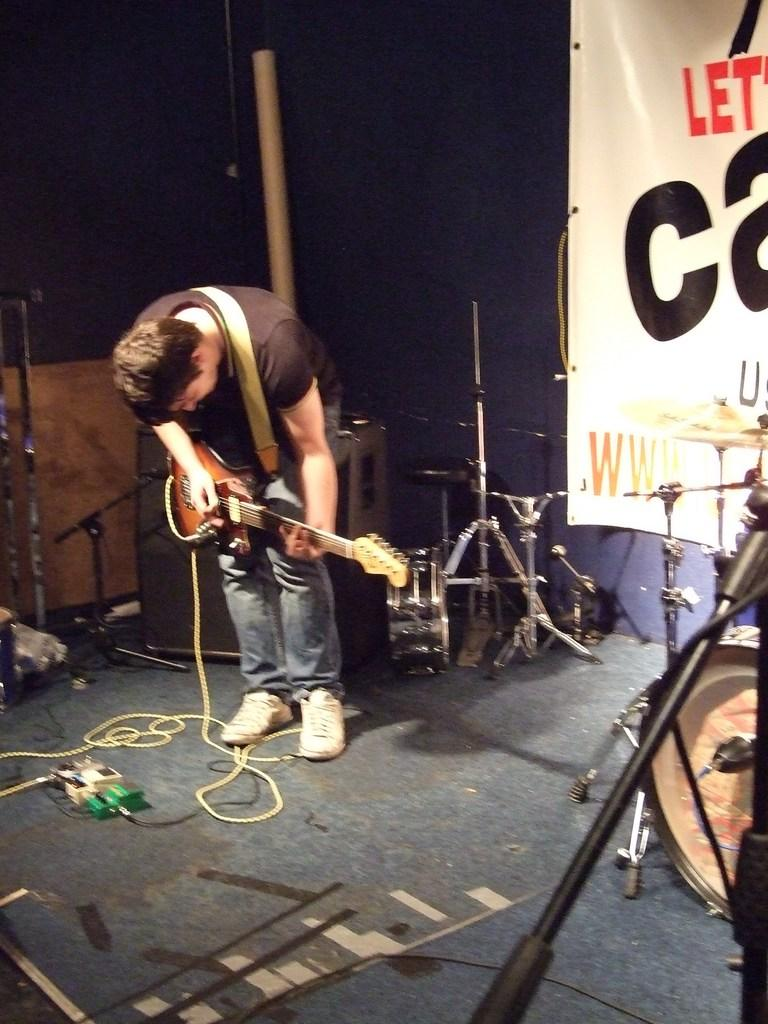Who is the main subject in the image? There is a man in the image. What is the man doing in the image? The man is playing a guitar. Where is the man located in the image? The man is on a stage. What other musical instruments can be seen in the image? There are other musical instruments in the image. What day of the week is the goose performing on the stage in the image? There is no goose present in the image, and therefore no performance by a goose can be observed. 